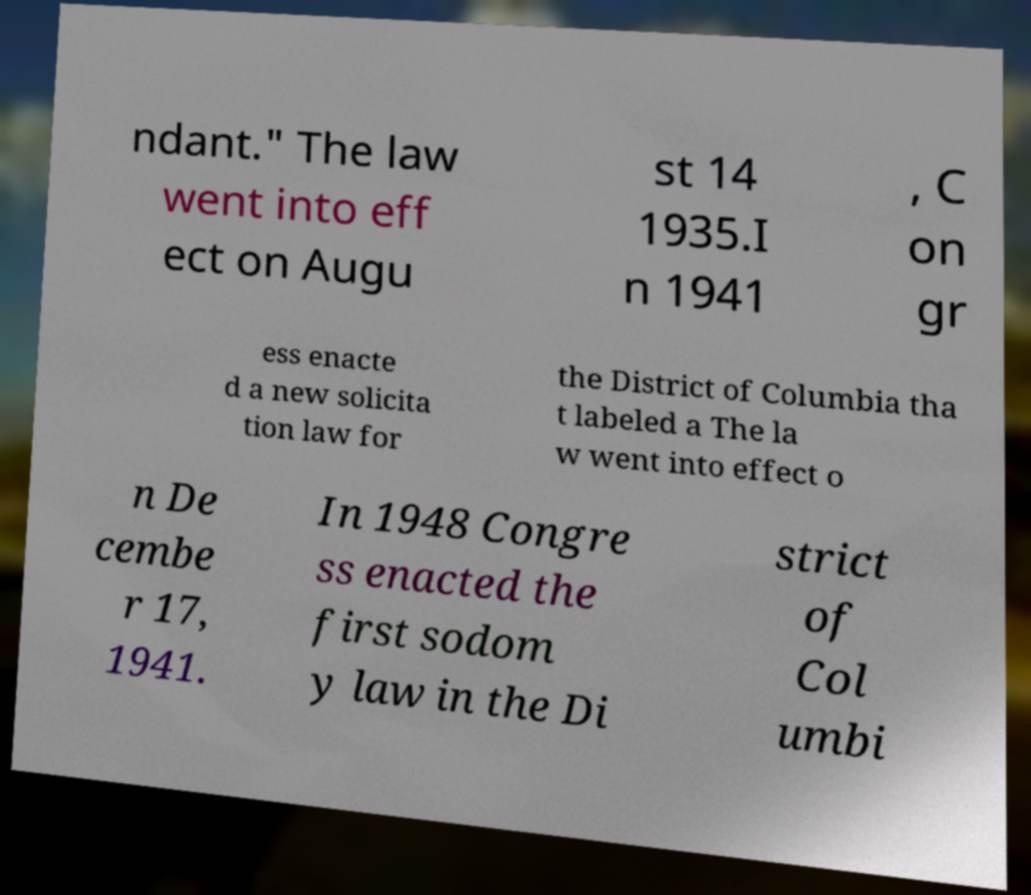What messages or text are displayed in this image? I need them in a readable, typed format. ndant." The law went into eff ect on Augu st 14 1935.I n 1941 , C on gr ess enacte d a new solicita tion law for the District of Columbia tha t labeled a The la w went into effect o n De cembe r 17, 1941. In 1948 Congre ss enacted the first sodom y law in the Di strict of Col umbi 